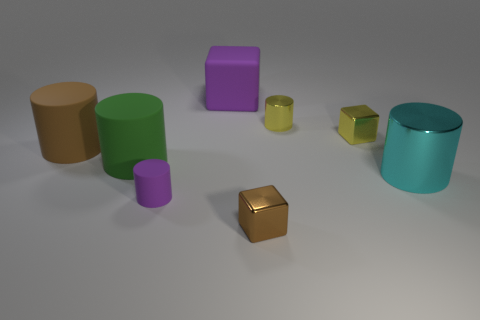Subtract all tiny cubes. How many cubes are left? 1 Add 1 big rubber cubes. How many objects exist? 9 Subtract 3 cylinders. How many cylinders are left? 2 Subtract all yellow cylinders. How many cylinders are left? 4 Subtract all cylinders. How many objects are left? 3 Subtract all cyan cubes. Subtract all blue cylinders. How many cubes are left? 3 Subtract all purple matte blocks. Subtract all cubes. How many objects are left? 4 Add 8 tiny brown blocks. How many tiny brown blocks are left? 9 Add 1 tiny shiny blocks. How many tiny shiny blocks exist? 3 Subtract 1 yellow blocks. How many objects are left? 7 